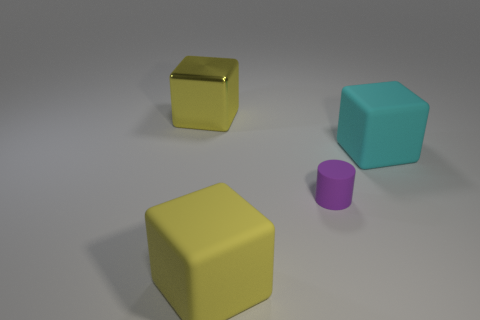What material is the big yellow cube that is behind the yellow thing that is in front of the big yellow shiny object?
Ensure brevity in your answer.  Metal. Are there any big yellow shiny objects on the left side of the tiny purple thing?
Your answer should be very brief. Yes. There is a cyan block; does it have the same size as the yellow object behind the yellow rubber cube?
Provide a succinct answer. Yes. There is a yellow shiny thing that is the same shape as the cyan rubber thing; what is its size?
Your answer should be very brief. Large. Does the yellow object in front of the large yellow shiny block have the same size as the yellow thing that is behind the cyan matte object?
Provide a succinct answer. Yes. How many large things are rubber cubes or objects?
Give a very brief answer. 3. How many things are behind the yellow matte thing and to the right of the big yellow shiny thing?
Provide a succinct answer. 2. Are the small thing and the big yellow cube that is in front of the tiny rubber thing made of the same material?
Keep it short and to the point. Yes. What number of purple things are either rubber cubes or large blocks?
Your answer should be very brief. 0. Are there any yellow metallic things of the same size as the cyan matte object?
Ensure brevity in your answer.  Yes. 